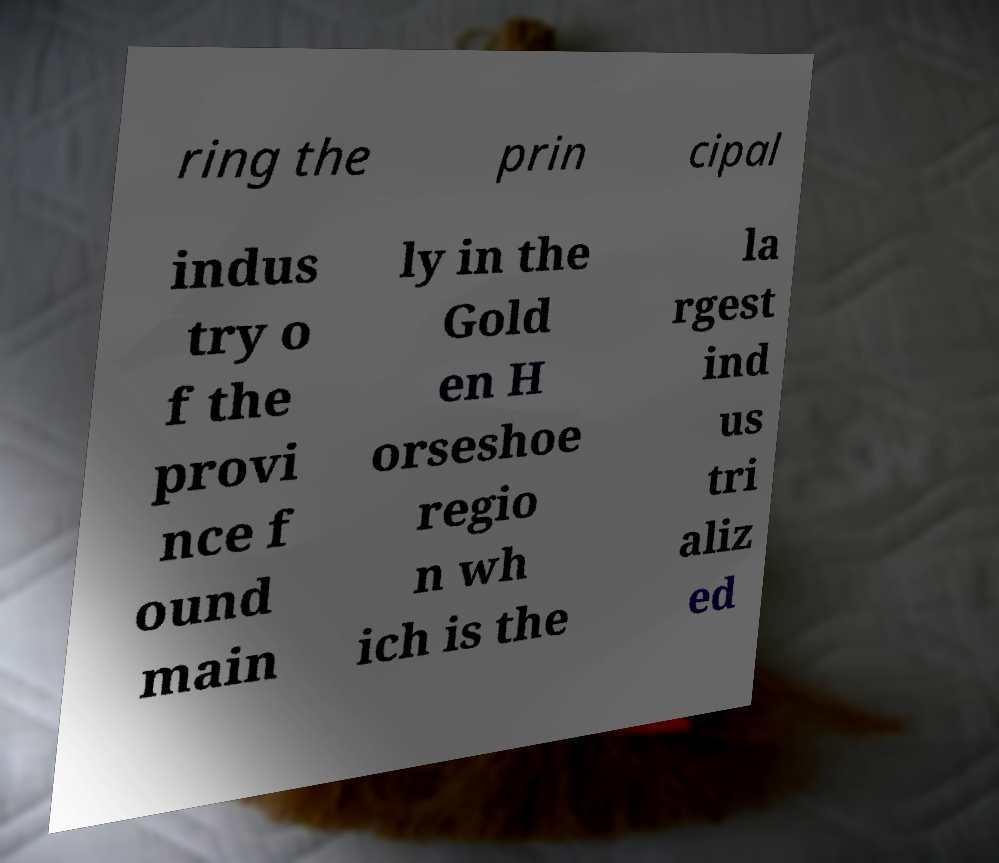Can you read and provide the text displayed in the image?This photo seems to have some interesting text. Can you extract and type it out for me? ring the prin cipal indus try o f the provi nce f ound main ly in the Gold en H orseshoe regio n wh ich is the la rgest ind us tri aliz ed 